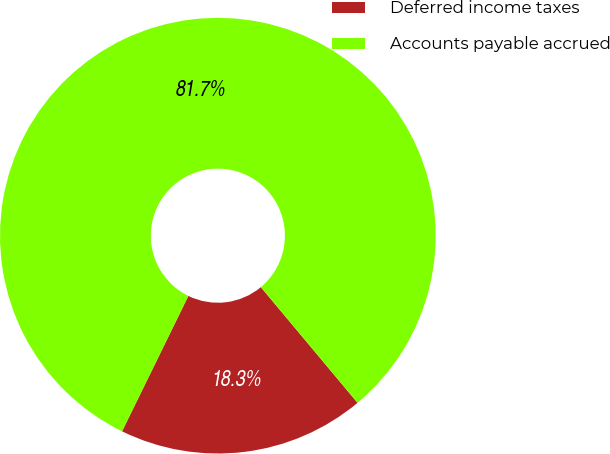<chart> <loc_0><loc_0><loc_500><loc_500><pie_chart><fcel>Deferred income taxes<fcel>Accounts payable accrued<nl><fcel>18.33%<fcel>81.67%<nl></chart> 